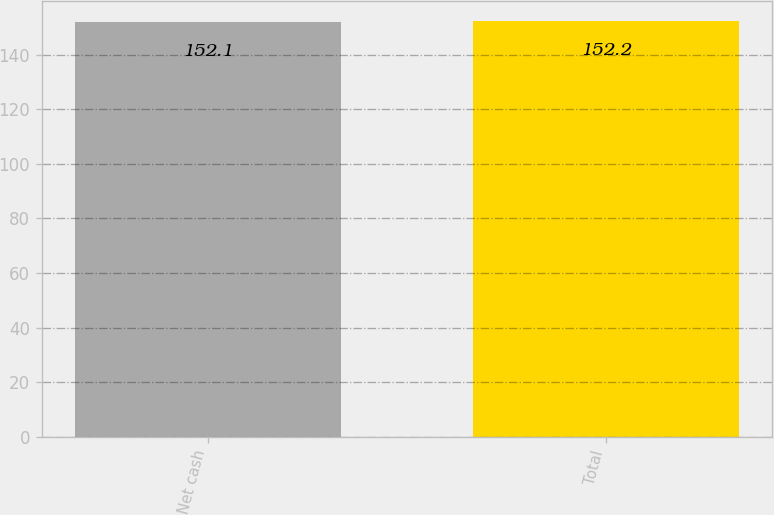<chart> <loc_0><loc_0><loc_500><loc_500><bar_chart><fcel>Net cash<fcel>Total<nl><fcel>152.1<fcel>152.2<nl></chart> 